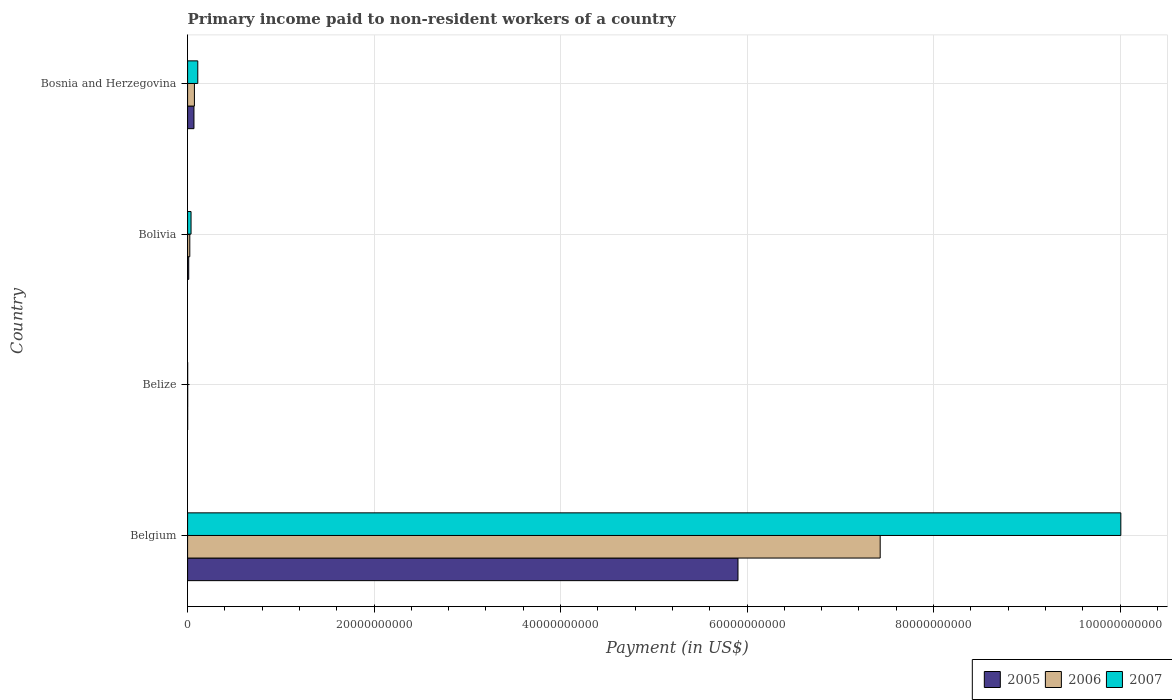How many groups of bars are there?
Your answer should be very brief. 4. Are the number of bars on each tick of the Y-axis equal?
Ensure brevity in your answer.  Yes. How many bars are there on the 4th tick from the top?
Provide a succinct answer. 3. In how many cases, is the number of bars for a given country not equal to the number of legend labels?
Provide a succinct answer. 0. What is the amount paid to workers in 2005 in Belize?
Give a very brief answer. 6.78e+06. Across all countries, what is the maximum amount paid to workers in 2005?
Provide a short and direct response. 5.90e+1. Across all countries, what is the minimum amount paid to workers in 2006?
Ensure brevity in your answer.  1.01e+07. In which country was the amount paid to workers in 2007 minimum?
Offer a very short reply. Belize. What is the total amount paid to workers in 2006 in the graph?
Your answer should be compact. 7.53e+1. What is the difference between the amount paid to workers in 2007 in Belize and that in Bosnia and Herzegovina?
Provide a succinct answer. -1.08e+09. What is the difference between the amount paid to workers in 2005 in Bolivia and the amount paid to workers in 2007 in Belize?
Offer a terse response. 1.14e+08. What is the average amount paid to workers in 2006 per country?
Your response must be concise. 1.88e+1. What is the difference between the amount paid to workers in 2005 and amount paid to workers in 2007 in Belize?
Keep it short and to the point. -1.86e+05. In how many countries, is the amount paid to workers in 2006 greater than 28000000000 US$?
Provide a succinct answer. 1. What is the ratio of the amount paid to workers in 2006 in Belize to that in Bolivia?
Give a very brief answer. 0.04. Is the amount paid to workers in 2007 in Belgium less than that in Bolivia?
Make the answer very short. No. Is the difference between the amount paid to workers in 2005 in Bolivia and Bosnia and Herzegovina greater than the difference between the amount paid to workers in 2007 in Bolivia and Bosnia and Herzegovina?
Offer a terse response. Yes. What is the difference between the highest and the second highest amount paid to workers in 2005?
Ensure brevity in your answer.  5.83e+1. What is the difference between the highest and the lowest amount paid to workers in 2006?
Ensure brevity in your answer.  7.43e+1. In how many countries, is the amount paid to workers in 2005 greater than the average amount paid to workers in 2005 taken over all countries?
Your answer should be very brief. 1. What does the 1st bar from the top in Belize represents?
Make the answer very short. 2007. Is it the case that in every country, the sum of the amount paid to workers in 2007 and amount paid to workers in 2005 is greater than the amount paid to workers in 2006?
Your answer should be compact. Yes. Are all the bars in the graph horizontal?
Your response must be concise. Yes. How many countries are there in the graph?
Provide a succinct answer. 4. Are the values on the major ticks of X-axis written in scientific E-notation?
Your response must be concise. No. How many legend labels are there?
Provide a succinct answer. 3. What is the title of the graph?
Your answer should be very brief. Primary income paid to non-resident workers of a country. What is the label or title of the X-axis?
Provide a succinct answer. Payment (in US$). What is the Payment (in US$) of 2005 in Belgium?
Your answer should be very brief. 5.90e+1. What is the Payment (in US$) of 2006 in Belgium?
Ensure brevity in your answer.  7.43e+1. What is the Payment (in US$) in 2007 in Belgium?
Offer a very short reply. 1.00e+11. What is the Payment (in US$) of 2005 in Belize?
Make the answer very short. 6.78e+06. What is the Payment (in US$) in 2006 in Belize?
Your response must be concise. 1.01e+07. What is the Payment (in US$) in 2007 in Belize?
Provide a succinct answer. 6.97e+06. What is the Payment (in US$) in 2005 in Bolivia?
Keep it short and to the point. 1.21e+08. What is the Payment (in US$) of 2006 in Bolivia?
Keep it short and to the point. 2.35e+08. What is the Payment (in US$) of 2007 in Bolivia?
Provide a short and direct response. 3.70e+08. What is the Payment (in US$) in 2005 in Bosnia and Herzegovina?
Provide a succinct answer. 6.82e+08. What is the Payment (in US$) of 2006 in Bosnia and Herzegovina?
Provide a succinct answer. 7.33e+08. What is the Payment (in US$) in 2007 in Bosnia and Herzegovina?
Your response must be concise. 1.09e+09. Across all countries, what is the maximum Payment (in US$) in 2005?
Ensure brevity in your answer.  5.90e+1. Across all countries, what is the maximum Payment (in US$) of 2006?
Your answer should be compact. 7.43e+1. Across all countries, what is the maximum Payment (in US$) of 2007?
Provide a short and direct response. 1.00e+11. Across all countries, what is the minimum Payment (in US$) of 2005?
Keep it short and to the point. 6.78e+06. Across all countries, what is the minimum Payment (in US$) of 2006?
Keep it short and to the point. 1.01e+07. Across all countries, what is the minimum Payment (in US$) of 2007?
Keep it short and to the point. 6.97e+06. What is the total Payment (in US$) in 2005 in the graph?
Keep it short and to the point. 5.98e+1. What is the total Payment (in US$) in 2006 in the graph?
Offer a very short reply. 7.53e+1. What is the total Payment (in US$) of 2007 in the graph?
Provide a short and direct response. 1.02e+11. What is the difference between the Payment (in US$) in 2005 in Belgium and that in Belize?
Your answer should be compact. 5.90e+1. What is the difference between the Payment (in US$) in 2006 in Belgium and that in Belize?
Keep it short and to the point. 7.43e+1. What is the difference between the Payment (in US$) in 2007 in Belgium and that in Belize?
Provide a succinct answer. 1.00e+11. What is the difference between the Payment (in US$) in 2005 in Belgium and that in Bolivia?
Your response must be concise. 5.89e+1. What is the difference between the Payment (in US$) in 2006 in Belgium and that in Bolivia?
Make the answer very short. 7.40e+1. What is the difference between the Payment (in US$) in 2007 in Belgium and that in Bolivia?
Offer a very short reply. 9.97e+1. What is the difference between the Payment (in US$) in 2005 in Belgium and that in Bosnia and Herzegovina?
Your answer should be compact. 5.83e+1. What is the difference between the Payment (in US$) in 2006 in Belgium and that in Bosnia and Herzegovina?
Provide a short and direct response. 7.35e+1. What is the difference between the Payment (in US$) in 2007 in Belgium and that in Bosnia and Herzegovina?
Provide a short and direct response. 9.90e+1. What is the difference between the Payment (in US$) of 2005 in Belize and that in Bolivia?
Ensure brevity in your answer.  -1.14e+08. What is the difference between the Payment (in US$) in 2006 in Belize and that in Bolivia?
Your answer should be very brief. -2.25e+08. What is the difference between the Payment (in US$) in 2007 in Belize and that in Bolivia?
Provide a succinct answer. -3.63e+08. What is the difference between the Payment (in US$) in 2005 in Belize and that in Bosnia and Herzegovina?
Keep it short and to the point. -6.76e+08. What is the difference between the Payment (in US$) in 2006 in Belize and that in Bosnia and Herzegovina?
Offer a very short reply. -7.22e+08. What is the difference between the Payment (in US$) of 2007 in Belize and that in Bosnia and Herzegovina?
Your answer should be compact. -1.08e+09. What is the difference between the Payment (in US$) of 2005 in Bolivia and that in Bosnia and Herzegovina?
Provide a short and direct response. -5.61e+08. What is the difference between the Payment (in US$) in 2006 in Bolivia and that in Bosnia and Herzegovina?
Offer a terse response. -4.97e+08. What is the difference between the Payment (in US$) in 2007 in Bolivia and that in Bosnia and Herzegovina?
Your answer should be very brief. -7.22e+08. What is the difference between the Payment (in US$) of 2005 in Belgium and the Payment (in US$) of 2006 in Belize?
Give a very brief answer. 5.90e+1. What is the difference between the Payment (in US$) in 2005 in Belgium and the Payment (in US$) in 2007 in Belize?
Keep it short and to the point. 5.90e+1. What is the difference between the Payment (in US$) of 2006 in Belgium and the Payment (in US$) of 2007 in Belize?
Ensure brevity in your answer.  7.43e+1. What is the difference between the Payment (in US$) of 2005 in Belgium and the Payment (in US$) of 2006 in Bolivia?
Make the answer very short. 5.88e+1. What is the difference between the Payment (in US$) in 2005 in Belgium and the Payment (in US$) in 2007 in Bolivia?
Your answer should be very brief. 5.87e+1. What is the difference between the Payment (in US$) in 2006 in Belgium and the Payment (in US$) in 2007 in Bolivia?
Your answer should be compact. 7.39e+1. What is the difference between the Payment (in US$) in 2005 in Belgium and the Payment (in US$) in 2006 in Bosnia and Herzegovina?
Ensure brevity in your answer.  5.83e+1. What is the difference between the Payment (in US$) in 2005 in Belgium and the Payment (in US$) in 2007 in Bosnia and Herzegovina?
Keep it short and to the point. 5.79e+1. What is the difference between the Payment (in US$) in 2006 in Belgium and the Payment (in US$) in 2007 in Bosnia and Herzegovina?
Provide a short and direct response. 7.32e+1. What is the difference between the Payment (in US$) in 2005 in Belize and the Payment (in US$) in 2006 in Bolivia?
Provide a succinct answer. -2.29e+08. What is the difference between the Payment (in US$) of 2005 in Belize and the Payment (in US$) of 2007 in Bolivia?
Keep it short and to the point. -3.63e+08. What is the difference between the Payment (in US$) in 2006 in Belize and the Payment (in US$) in 2007 in Bolivia?
Provide a succinct answer. -3.60e+08. What is the difference between the Payment (in US$) of 2005 in Belize and the Payment (in US$) of 2006 in Bosnia and Herzegovina?
Provide a succinct answer. -7.26e+08. What is the difference between the Payment (in US$) of 2005 in Belize and the Payment (in US$) of 2007 in Bosnia and Herzegovina?
Your answer should be compact. -1.09e+09. What is the difference between the Payment (in US$) in 2006 in Belize and the Payment (in US$) in 2007 in Bosnia and Herzegovina?
Offer a terse response. -1.08e+09. What is the difference between the Payment (in US$) in 2005 in Bolivia and the Payment (in US$) in 2006 in Bosnia and Herzegovina?
Your answer should be very brief. -6.11e+08. What is the difference between the Payment (in US$) of 2005 in Bolivia and the Payment (in US$) of 2007 in Bosnia and Herzegovina?
Offer a very short reply. -9.71e+08. What is the difference between the Payment (in US$) of 2006 in Bolivia and the Payment (in US$) of 2007 in Bosnia and Herzegovina?
Offer a very short reply. -8.56e+08. What is the average Payment (in US$) in 2005 per country?
Provide a succinct answer. 1.50e+1. What is the average Payment (in US$) of 2006 per country?
Make the answer very short. 1.88e+1. What is the average Payment (in US$) of 2007 per country?
Your response must be concise. 2.54e+1. What is the difference between the Payment (in US$) of 2005 and Payment (in US$) of 2006 in Belgium?
Provide a succinct answer. -1.52e+1. What is the difference between the Payment (in US$) in 2005 and Payment (in US$) in 2007 in Belgium?
Provide a succinct answer. -4.11e+1. What is the difference between the Payment (in US$) in 2006 and Payment (in US$) in 2007 in Belgium?
Offer a terse response. -2.58e+1. What is the difference between the Payment (in US$) of 2005 and Payment (in US$) of 2006 in Belize?
Provide a short and direct response. -3.32e+06. What is the difference between the Payment (in US$) of 2005 and Payment (in US$) of 2007 in Belize?
Your answer should be compact. -1.86e+05. What is the difference between the Payment (in US$) of 2006 and Payment (in US$) of 2007 in Belize?
Provide a short and direct response. 3.13e+06. What is the difference between the Payment (in US$) in 2005 and Payment (in US$) in 2006 in Bolivia?
Your answer should be compact. -1.14e+08. What is the difference between the Payment (in US$) of 2005 and Payment (in US$) of 2007 in Bolivia?
Keep it short and to the point. -2.49e+08. What is the difference between the Payment (in US$) of 2006 and Payment (in US$) of 2007 in Bolivia?
Offer a very short reply. -1.34e+08. What is the difference between the Payment (in US$) of 2005 and Payment (in US$) of 2006 in Bosnia and Herzegovina?
Provide a short and direct response. -5.03e+07. What is the difference between the Payment (in US$) in 2005 and Payment (in US$) in 2007 in Bosnia and Herzegovina?
Provide a succinct answer. -4.10e+08. What is the difference between the Payment (in US$) in 2006 and Payment (in US$) in 2007 in Bosnia and Herzegovina?
Provide a succinct answer. -3.59e+08. What is the ratio of the Payment (in US$) of 2005 in Belgium to that in Belize?
Provide a short and direct response. 8704.96. What is the ratio of the Payment (in US$) in 2006 in Belgium to that in Belize?
Provide a succinct answer. 7353.89. What is the ratio of the Payment (in US$) in 2007 in Belgium to that in Belize?
Your response must be concise. 1.44e+04. What is the ratio of the Payment (in US$) in 2005 in Belgium to that in Bolivia?
Offer a terse response. 486.92. What is the ratio of the Payment (in US$) in 2006 in Belgium to that in Bolivia?
Give a very brief answer. 315.48. What is the ratio of the Payment (in US$) of 2007 in Belgium to that in Bolivia?
Give a very brief answer. 270.62. What is the ratio of the Payment (in US$) in 2005 in Belgium to that in Bosnia and Herzegovina?
Give a very brief answer. 86.51. What is the ratio of the Payment (in US$) of 2006 in Belgium to that in Bosnia and Herzegovina?
Provide a short and direct response. 101.39. What is the ratio of the Payment (in US$) in 2007 in Belgium to that in Bosnia and Herzegovina?
Keep it short and to the point. 91.66. What is the ratio of the Payment (in US$) in 2005 in Belize to that in Bolivia?
Your answer should be compact. 0.06. What is the ratio of the Payment (in US$) in 2006 in Belize to that in Bolivia?
Your answer should be very brief. 0.04. What is the ratio of the Payment (in US$) of 2007 in Belize to that in Bolivia?
Your response must be concise. 0.02. What is the ratio of the Payment (in US$) in 2005 in Belize to that in Bosnia and Herzegovina?
Provide a succinct answer. 0.01. What is the ratio of the Payment (in US$) of 2006 in Belize to that in Bosnia and Herzegovina?
Your answer should be compact. 0.01. What is the ratio of the Payment (in US$) in 2007 in Belize to that in Bosnia and Herzegovina?
Your answer should be compact. 0.01. What is the ratio of the Payment (in US$) of 2005 in Bolivia to that in Bosnia and Herzegovina?
Keep it short and to the point. 0.18. What is the ratio of the Payment (in US$) of 2006 in Bolivia to that in Bosnia and Herzegovina?
Ensure brevity in your answer.  0.32. What is the ratio of the Payment (in US$) of 2007 in Bolivia to that in Bosnia and Herzegovina?
Make the answer very short. 0.34. What is the difference between the highest and the second highest Payment (in US$) in 2005?
Offer a very short reply. 5.83e+1. What is the difference between the highest and the second highest Payment (in US$) of 2006?
Offer a terse response. 7.35e+1. What is the difference between the highest and the second highest Payment (in US$) in 2007?
Offer a terse response. 9.90e+1. What is the difference between the highest and the lowest Payment (in US$) of 2005?
Your response must be concise. 5.90e+1. What is the difference between the highest and the lowest Payment (in US$) in 2006?
Provide a succinct answer. 7.43e+1. What is the difference between the highest and the lowest Payment (in US$) of 2007?
Ensure brevity in your answer.  1.00e+11. 